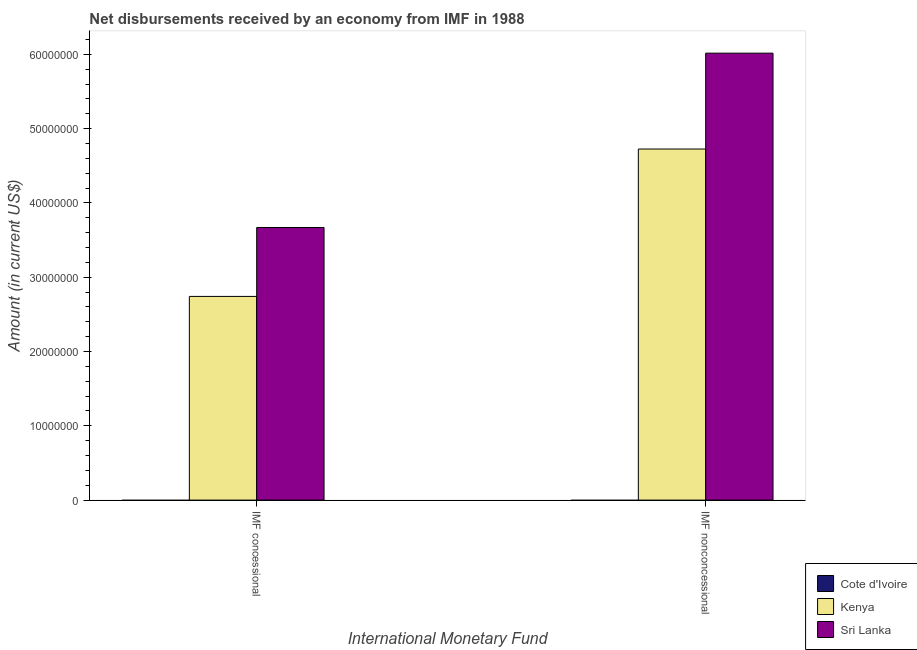Are the number of bars on each tick of the X-axis equal?
Your answer should be very brief. Yes. How many bars are there on the 2nd tick from the left?
Ensure brevity in your answer.  2. How many bars are there on the 1st tick from the right?
Your answer should be compact. 2. What is the label of the 1st group of bars from the left?
Your answer should be compact. IMF concessional. What is the net non concessional disbursements from imf in Sri Lanka?
Provide a succinct answer. 6.02e+07. Across all countries, what is the maximum net concessional disbursements from imf?
Your answer should be compact. 3.67e+07. In which country was the net concessional disbursements from imf maximum?
Make the answer very short. Sri Lanka. What is the total net concessional disbursements from imf in the graph?
Provide a short and direct response. 6.41e+07. What is the difference between the net concessional disbursements from imf in Kenya and that in Sri Lanka?
Your response must be concise. -9.28e+06. What is the difference between the net concessional disbursements from imf in Cote d'Ivoire and the net non concessional disbursements from imf in Kenya?
Your answer should be very brief. -4.73e+07. What is the average net concessional disbursements from imf per country?
Provide a short and direct response. 2.14e+07. What is the difference between the net non concessional disbursements from imf and net concessional disbursements from imf in Kenya?
Offer a very short reply. 1.98e+07. Is the net concessional disbursements from imf in Kenya less than that in Sri Lanka?
Your answer should be compact. Yes. How many bars are there?
Provide a succinct answer. 4. What is the difference between two consecutive major ticks on the Y-axis?
Keep it short and to the point. 1.00e+07. Does the graph contain grids?
Your answer should be very brief. No. What is the title of the graph?
Make the answer very short. Net disbursements received by an economy from IMF in 1988. What is the label or title of the X-axis?
Your response must be concise. International Monetary Fund. What is the label or title of the Y-axis?
Your answer should be very brief. Amount (in current US$). What is the Amount (in current US$) in Kenya in IMF concessional?
Keep it short and to the point. 2.74e+07. What is the Amount (in current US$) in Sri Lanka in IMF concessional?
Your response must be concise. 3.67e+07. What is the Amount (in current US$) in Kenya in IMF nonconcessional?
Your response must be concise. 4.73e+07. What is the Amount (in current US$) of Sri Lanka in IMF nonconcessional?
Provide a short and direct response. 6.02e+07. Across all International Monetary Fund, what is the maximum Amount (in current US$) of Kenya?
Keep it short and to the point. 4.73e+07. Across all International Monetary Fund, what is the maximum Amount (in current US$) of Sri Lanka?
Offer a terse response. 6.02e+07. Across all International Monetary Fund, what is the minimum Amount (in current US$) in Kenya?
Provide a succinct answer. 2.74e+07. Across all International Monetary Fund, what is the minimum Amount (in current US$) of Sri Lanka?
Provide a succinct answer. 3.67e+07. What is the total Amount (in current US$) in Cote d'Ivoire in the graph?
Keep it short and to the point. 0. What is the total Amount (in current US$) of Kenya in the graph?
Provide a succinct answer. 7.47e+07. What is the total Amount (in current US$) of Sri Lanka in the graph?
Provide a short and direct response. 9.69e+07. What is the difference between the Amount (in current US$) of Kenya in IMF concessional and that in IMF nonconcessional?
Provide a short and direct response. -1.98e+07. What is the difference between the Amount (in current US$) of Sri Lanka in IMF concessional and that in IMF nonconcessional?
Your answer should be compact. -2.35e+07. What is the difference between the Amount (in current US$) of Kenya in IMF concessional and the Amount (in current US$) of Sri Lanka in IMF nonconcessional?
Offer a terse response. -3.27e+07. What is the average Amount (in current US$) of Cote d'Ivoire per International Monetary Fund?
Provide a short and direct response. 0. What is the average Amount (in current US$) in Kenya per International Monetary Fund?
Provide a succinct answer. 3.73e+07. What is the average Amount (in current US$) in Sri Lanka per International Monetary Fund?
Offer a terse response. 4.84e+07. What is the difference between the Amount (in current US$) of Kenya and Amount (in current US$) of Sri Lanka in IMF concessional?
Make the answer very short. -9.28e+06. What is the difference between the Amount (in current US$) of Kenya and Amount (in current US$) of Sri Lanka in IMF nonconcessional?
Make the answer very short. -1.29e+07. What is the ratio of the Amount (in current US$) of Kenya in IMF concessional to that in IMF nonconcessional?
Provide a short and direct response. 0.58. What is the ratio of the Amount (in current US$) of Sri Lanka in IMF concessional to that in IMF nonconcessional?
Keep it short and to the point. 0.61. What is the difference between the highest and the second highest Amount (in current US$) in Kenya?
Offer a terse response. 1.98e+07. What is the difference between the highest and the second highest Amount (in current US$) in Sri Lanka?
Your answer should be compact. 2.35e+07. What is the difference between the highest and the lowest Amount (in current US$) in Kenya?
Offer a very short reply. 1.98e+07. What is the difference between the highest and the lowest Amount (in current US$) of Sri Lanka?
Provide a short and direct response. 2.35e+07. 